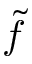Convert formula to latex. <formula><loc_0><loc_0><loc_500><loc_500>\tilde { f }</formula> 